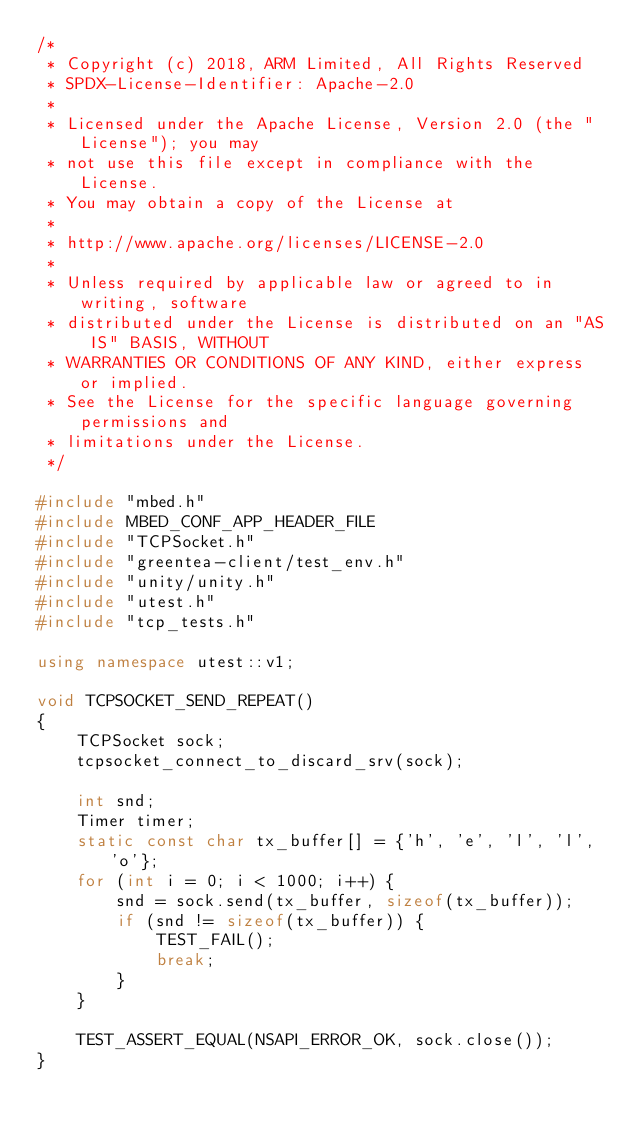<code> <loc_0><loc_0><loc_500><loc_500><_C++_>/*
 * Copyright (c) 2018, ARM Limited, All Rights Reserved
 * SPDX-License-Identifier: Apache-2.0
 *
 * Licensed under the Apache License, Version 2.0 (the "License"); you may
 * not use this file except in compliance with the License.
 * You may obtain a copy of the License at
 *
 * http://www.apache.org/licenses/LICENSE-2.0
 *
 * Unless required by applicable law or agreed to in writing, software
 * distributed under the License is distributed on an "AS IS" BASIS, WITHOUT
 * WARRANTIES OR CONDITIONS OF ANY KIND, either express or implied.
 * See the License for the specific language governing permissions and
 * limitations under the License.
 */

#include "mbed.h"
#include MBED_CONF_APP_HEADER_FILE
#include "TCPSocket.h"
#include "greentea-client/test_env.h"
#include "unity/unity.h"
#include "utest.h"
#include "tcp_tests.h"

using namespace utest::v1;

void TCPSOCKET_SEND_REPEAT()
{
    TCPSocket sock;
    tcpsocket_connect_to_discard_srv(sock);

    int snd;
    Timer timer;
    static const char tx_buffer[] = {'h', 'e', 'l', 'l', 'o'};
    for (int i = 0; i < 1000; i++) {
        snd = sock.send(tx_buffer, sizeof(tx_buffer));
        if (snd != sizeof(tx_buffer)) {
            TEST_FAIL();
            break;
        }
    }

    TEST_ASSERT_EQUAL(NSAPI_ERROR_OK, sock.close());
}
</code> 